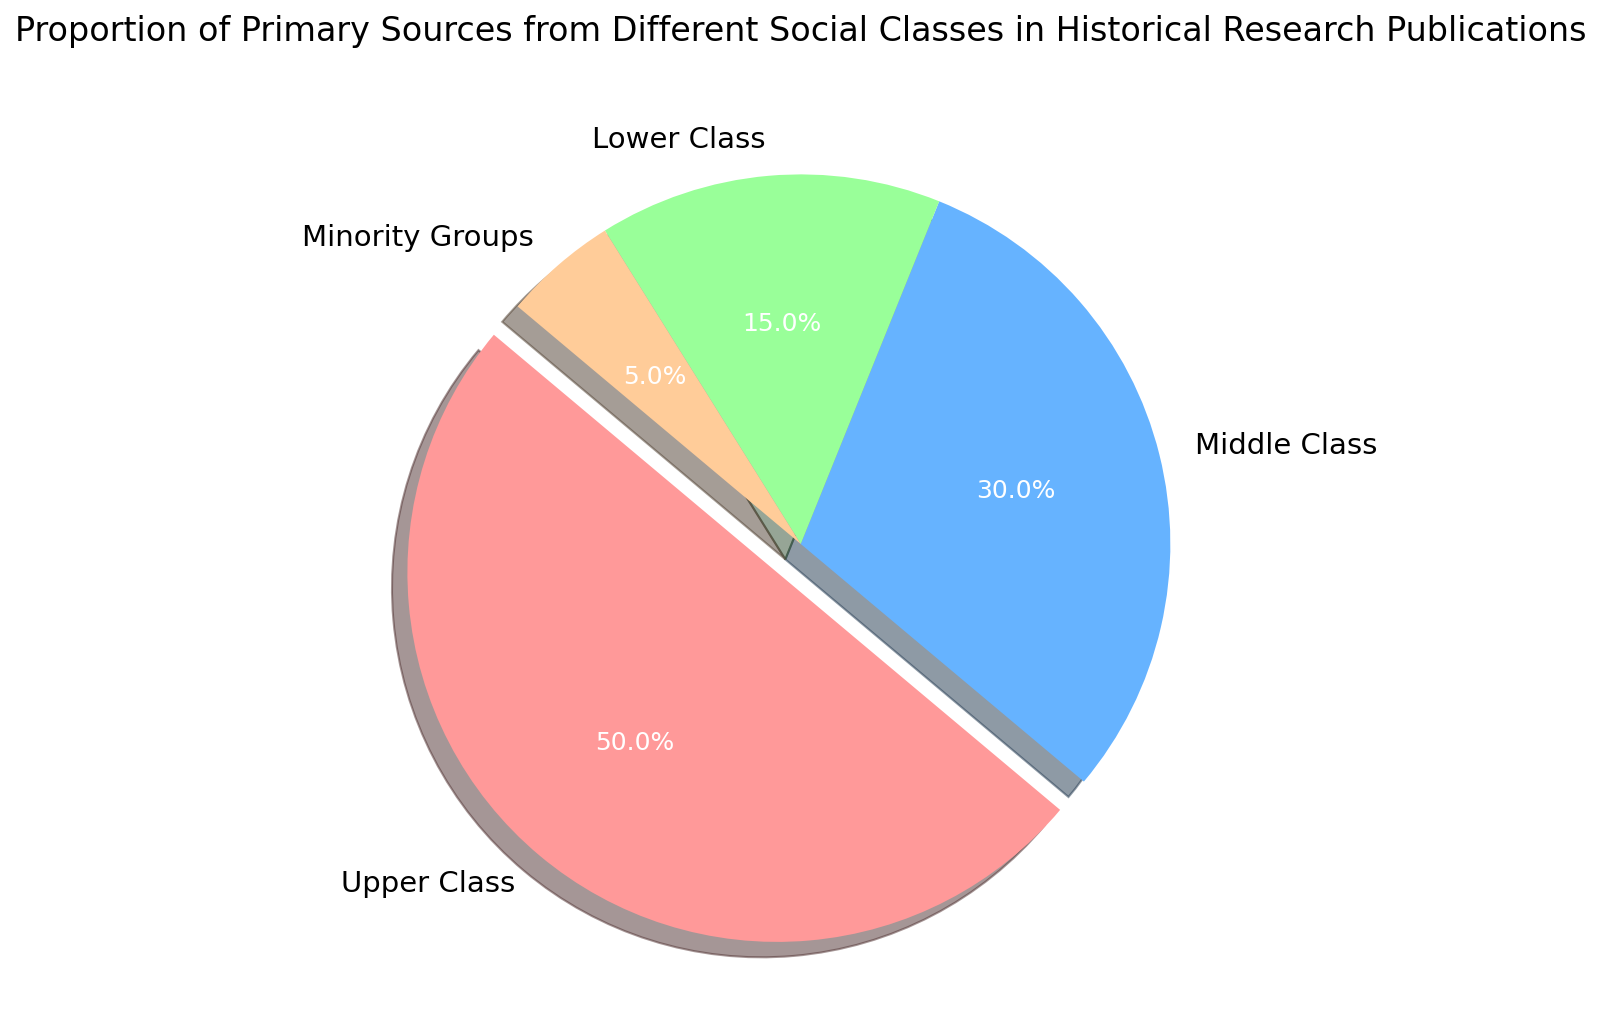what percentage of the primary sources are from the middle and lower classes combined? Add the proportions of the middle class (30%) and lower class (15%). 30% + 15% = 45%
Answer: 45% Which group has the smallest proportion of primary sources? The chart shows four groups: Upper Class, Middle Class, Lower Class, and Minority Groups. The Minority Groups slice is the smallest.
Answer: Minority Groups What is the difference in proportion between the Upper Class and the Lower Class sources? Subtract the proportion of the lower class (15%) from the upper class (50%). 50% - 15% = 35%
Answer: 35% Is the proportion of sources from the Middle Class greater or less than the proportion from the Lower Class? Compare the proportions of the middle class (30%) and the lower class (15%). 30% > 15%
Answer: Greater Which slice of the pie chart is represented in red? Identify the color associated with each slice of the pie chart. The slice corresponding to the Upper Class is shown in red.
Answer: Upper Class 